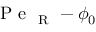Convert formula to latex. <formula><loc_0><loc_0><loc_500><loc_500>P e _ { R } - \phi _ { 0 }</formula> 